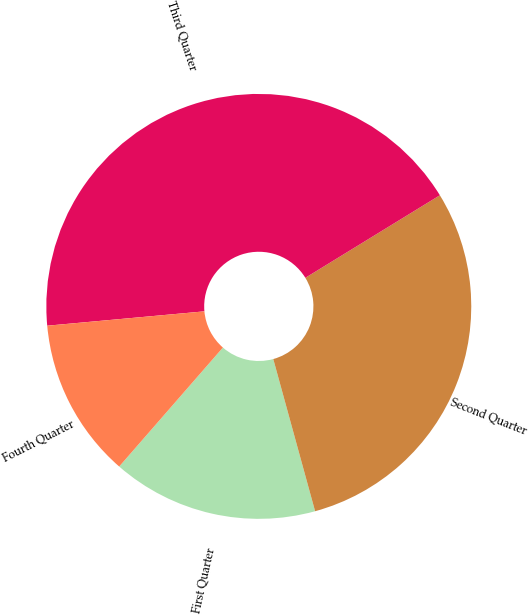<chart> <loc_0><loc_0><loc_500><loc_500><pie_chart><fcel>First Quarter<fcel>Second Quarter<fcel>Third Quarter<fcel>Fourth Quarter<nl><fcel>15.68%<fcel>29.49%<fcel>42.69%<fcel>12.14%<nl></chart> 